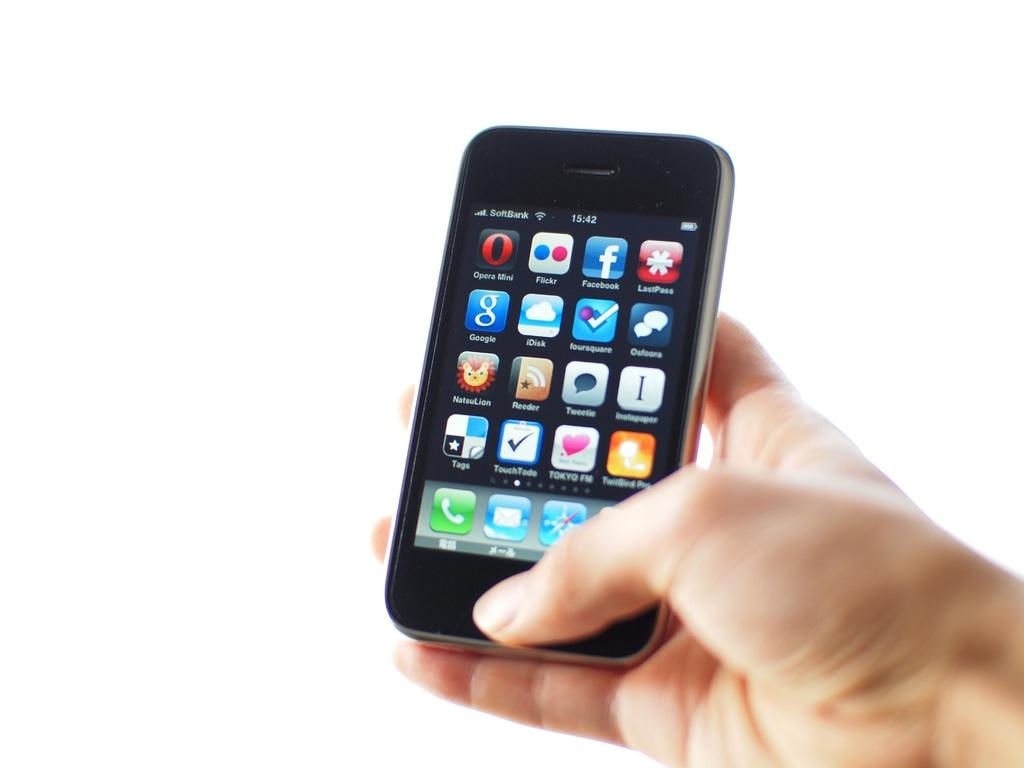<image>
Summarize the visual content of the image. Someone holding a smartphone with the app Opera Mini in the upper left hand corner of the screen. 